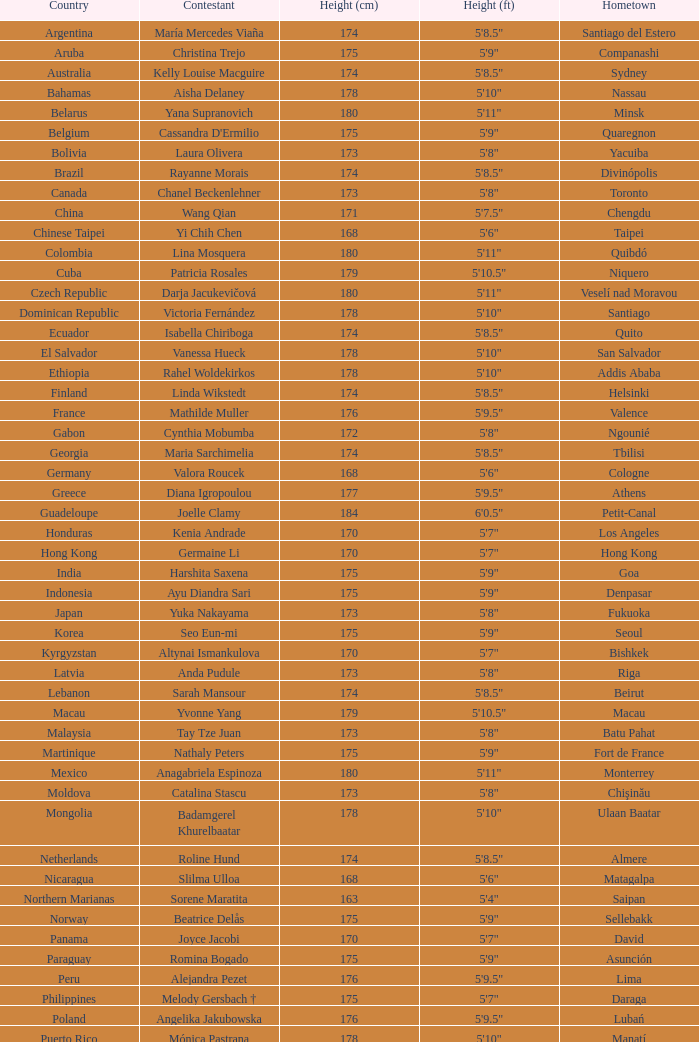What is Cynthia Mobumba's height? 5'8". Would you mind parsing the complete table? {'header': ['Country', 'Contestant', 'Height (cm)', 'Height (ft)', 'Hometown'], 'rows': [['Argentina', 'María Mercedes Viaña', '174', '5\'8.5"', 'Santiago del Estero'], ['Aruba', 'Christina Trejo', '175', '5\'9"', 'Companashi'], ['Australia', 'Kelly Louise Macguire', '174', '5\'8.5"', 'Sydney'], ['Bahamas', 'Aisha Delaney', '178', '5\'10"', 'Nassau'], ['Belarus', 'Yana Supranovich', '180', '5\'11"', 'Minsk'], ['Belgium', "Cassandra D'Ermilio", '175', '5\'9"', 'Quaregnon'], ['Bolivia', 'Laura Olivera', '173', '5\'8"', 'Yacuiba'], ['Brazil', 'Rayanne Morais', '174', '5\'8.5"', 'Divinópolis'], ['Canada', 'Chanel Beckenlehner', '173', '5\'8"', 'Toronto'], ['China', 'Wang Qian', '171', '5\'7.5"', 'Chengdu'], ['Chinese Taipei', 'Yi Chih Chen', '168', '5\'6"', 'Taipei'], ['Colombia', 'Lina Mosquera', '180', '5\'11"', 'Quibdó'], ['Cuba', 'Patricia Rosales', '179', '5\'10.5"', 'Niquero'], ['Czech Republic', 'Darja Jacukevičová', '180', '5\'11"', 'Veselí nad Moravou'], ['Dominican Republic', 'Victoria Fernández', '178', '5\'10"', 'Santiago'], ['Ecuador', 'Isabella Chiriboga', '174', '5\'8.5"', 'Quito'], ['El Salvador', 'Vanessa Hueck', '178', '5\'10"', 'San Salvador'], ['Ethiopia', 'Rahel Woldekirkos', '178', '5\'10"', 'Addis Ababa'], ['Finland', 'Linda Wikstedt', '174', '5\'8.5"', 'Helsinki'], ['France', 'Mathilde Muller', '176', '5\'9.5"', 'Valence'], ['Gabon', 'Cynthia Mobumba', '172', '5\'8"', 'Ngounié'], ['Georgia', 'Maria Sarchimelia', '174', '5\'8.5"', 'Tbilisi'], ['Germany', 'Valora Roucek', '168', '5\'6"', 'Cologne'], ['Greece', 'Diana Igropoulou', '177', '5\'9.5"', 'Athens'], ['Guadeloupe', 'Joelle Clamy', '184', '6\'0.5"', 'Petit-Canal'], ['Honduras', 'Kenia Andrade', '170', '5\'7"', 'Los Angeles'], ['Hong Kong', 'Germaine Li', '170', '5\'7"', 'Hong Kong'], ['India', 'Harshita Saxena', '175', '5\'9"', 'Goa'], ['Indonesia', 'Ayu Diandra Sari', '175', '5\'9"', 'Denpasar'], ['Japan', 'Yuka Nakayama', '173', '5\'8"', 'Fukuoka'], ['Korea', 'Seo Eun-mi', '175', '5\'9"', 'Seoul'], ['Kyrgyzstan', 'Altynai Ismankulova', '170', '5\'7"', 'Bishkek'], ['Latvia', 'Anda Pudule', '173', '5\'8"', 'Riga'], ['Lebanon', 'Sarah Mansour', '174', '5\'8.5"', 'Beirut'], ['Macau', 'Yvonne Yang', '179', '5\'10.5"', 'Macau'], ['Malaysia', 'Tay Tze Juan', '173', '5\'8"', 'Batu Pahat'], ['Martinique', 'Nathaly Peters', '175', '5\'9"', 'Fort de France'], ['Mexico', 'Anagabriela Espinoza', '180', '5\'11"', 'Monterrey'], ['Moldova', 'Catalina Stascu', '173', '5\'8"', 'Chişinău'], ['Mongolia', 'Badamgerel Khurelbaatar', '178', '5\'10"', 'Ulaan Baatar'], ['Netherlands', 'Roline Hund', '174', '5\'8.5"', 'Almere'], ['Nicaragua', 'Slilma Ulloa', '168', '5\'6"', 'Matagalpa'], ['Northern Marianas', 'Sorene Maratita', '163', '5\'4"', 'Saipan'], ['Norway', 'Beatrice Delås', '175', '5\'9"', 'Sellebakk'], ['Panama', 'Joyce Jacobi', '170', '5\'7"', 'David'], ['Paraguay', 'Romina Bogado', '175', '5\'9"', 'Asunción'], ['Peru', 'Alejandra Pezet', '176', '5\'9.5"', 'Lima'], ['Philippines', 'Melody Gersbach †', '175', '5\'7"', 'Daraga'], ['Poland', 'Angelika Jakubowska', '176', '5\'9.5"', 'Lubań'], ['Puerto Rico', 'Mónica Pastrana', '178', '5\'10"', 'Manatí'], ['Romania', 'Iuliana Capsuc', '174', '5\'8.5"', 'Bucharest'], ['Russia', 'Ksenia Hrabovskaya', '176', '5\'9.5"', 'Khabarovsk'], ['Singapore', 'Annabelle Liang', '169', '5\'6.5"', 'Singapore'], ['Slovakia', 'Soňa Skoncová', '174', '5\'8.5"', 'Prievidza'], ['South Africa', 'Bokang Montjane', '174', '5\'8.5"', 'Johannesburg'], ['Spain', 'Melania Santiago', '174', '5\'8.5"', 'Málaga'], ['Sudan', 'Suna William', '168', '5\'6"', 'Darfur'], ['Tanzania', 'Illuminata James', '176', '5\'9.5"', 'Mwanza'], ['Thailand', 'Picha Nampradit', '178', '5\'10"', 'Kanchanaburi'], ['Turkey', 'Begüm Yılmaz', '180', '5\'11"', 'Izmir'], ['Uganda', 'Pierra Akwero', '177', '5\'9.5"', 'Entebbe'], ['United Kingdom', 'Chloe-Beth Morgan', '171', '5\'7.5"', 'Cwmbran'], ['USA', 'Aileen Jan Yap', '170', '5\'6"', 'Houston'], ['Venezuela', 'Laksmi Rodríguez', '178', '5\'10"', 'Caracas'], ['Vietnam', 'Trần Thị Quỳnh', '175', '5\'9"', 'Hai Phong']]} 